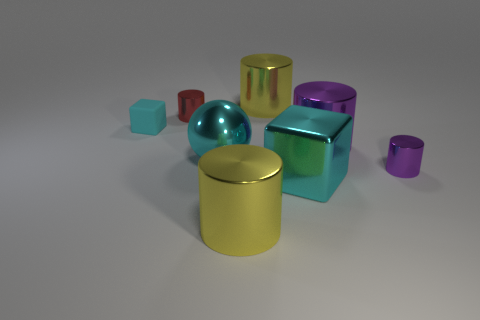Subtract all small cylinders. How many cylinders are left? 3 Add 1 small red cylinders. How many objects exist? 9 Subtract all purple cubes. How many purple cylinders are left? 2 Subtract all purple cylinders. How many cylinders are left? 3 Subtract all cylinders. How many objects are left? 3 Subtract all brown rubber balls. Subtract all cyan rubber objects. How many objects are left? 7 Add 1 red objects. How many red objects are left? 2 Add 8 tiny brown blocks. How many tiny brown blocks exist? 8 Subtract 2 cyan blocks. How many objects are left? 6 Subtract 1 balls. How many balls are left? 0 